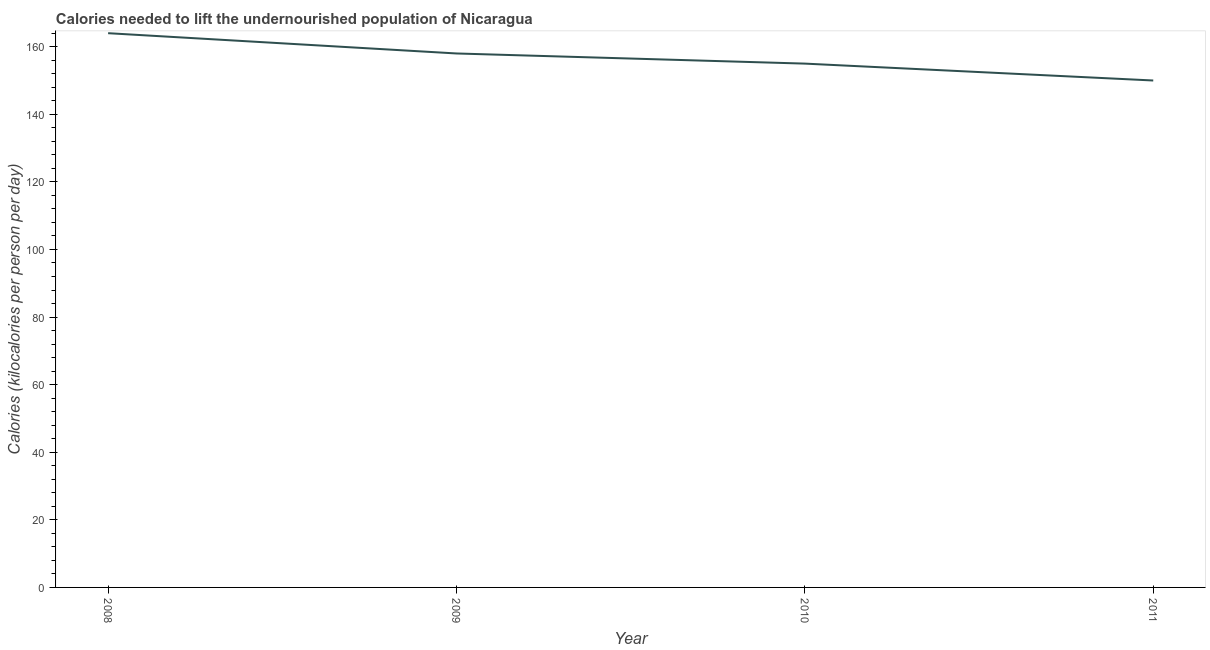What is the depth of food deficit in 2008?
Keep it short and to the point. 164. Across all years, what is the maximum depth of food deficit?
Ensure brevity in your answer.  164. Across all years, what is the minimum depth of food deficit?
Make the answer very short. 150. In which year was the depth of food deficit maximum?
Provide a short and direct response. 2008. In which year was the depth of food deficit minimum?
Your response must be concise. 2011. What is the sum of the depth of food deficit?
Keep it short and to the point. 627. What is the difference between the depth of food deficit in 2010 and 2011?
Give a very brief answer. 5. What is the average depth of food deficit per year?
Offer a very short reply. 156.75. What is the median depth of food deficit?
Offer a terse response. 156.5. In how many years, is the depth of food deficit greater than 156 kilocalories?
Keep it short and to the point. 2. What is the ratio of the depth of food deficit in 2009 to that in 2011?
Keep it short and to the point. 1.05. Is the depth of food deficit in 2009 less than that in 2011?
Your response must be concise. No. What is the difference between the highest and the second highest depth of food deficit?
Make the answer very short. 6. Is the sum of the depth of food deficit in 2008 and 2011 greater than the maximum depth of food deficit across all years?
Offer a terse response. Yes. What is the difference between the highest and the lowest depth of food deficit?
Provide a short and direct response. 14. How many lines are there?
Offer a very short reply. 1. How many years are there in the graph?
Ensure brevity in your answer.  4. What is the difference between two consecutive major ticks on the Y-axis?
Your response must be concise. 20. Does the graph contain any zero values?
Provide a short and direct response. No. What is the title of the graph?
Provide a short and direct response. Calories needed to lift the undernourished population of Nicaragua. What is the label or title of the X-axis?
Your answer should be compact. Year. What is the label or title of the Y-axis?
Keep it short and to the point. Calories (kilocalories per person per day). What is the Calories (kilocalories per person per day) of 2008?
Your response must be concise. 164. What is the Calories (kilocalories per person per day) in 2009?
Your answer should be very brief. 158. What is the Calories (kilocalories per person per day) in 2010?
Make the answer very short. 155. What is the Calories (kilocalories per person per day) in 2011?
Offer a very short reply. 150. What is the difference between the Calories (kilocalories per person per day) in 2008 and 2009?
Give a very brief answer. 6. What is the difference between the Calories (kilocalories per person per day) in 2008 and 2011?
Provide a succinct answer. 14. What is the difference between the Calories (kilocalories per person per day) in 2009 and 2010?
Your answer should be very brief. 3. What is the ratio of the Calories (kilocalories per person per day) in 2008 to that in 2009?
Give a very brief answer. 1.04. What is the ratio of the Calories (kilocalories per person per day) in 2008 to that in 2010?
Make the answer very short. 1.06. What is the ratio of the Calories (kilocalories per person per day) in 2008 to that in 2011?
Keep it short and to the point. 1.09. What is the ratio of the Calories (kilocalories per person per day) in 2009 to that in 2010?
Your answer should be very brief. 1.02. What is the ratio of the Calories (kilocalories per person per day) in 2009 to that in 2011?
Your answer should be very brief. 1.05. What is the ratio of the Calories (kilocalories per person per day) in 2010 to that in 2011?
Offer a very short reply. 1.03. 